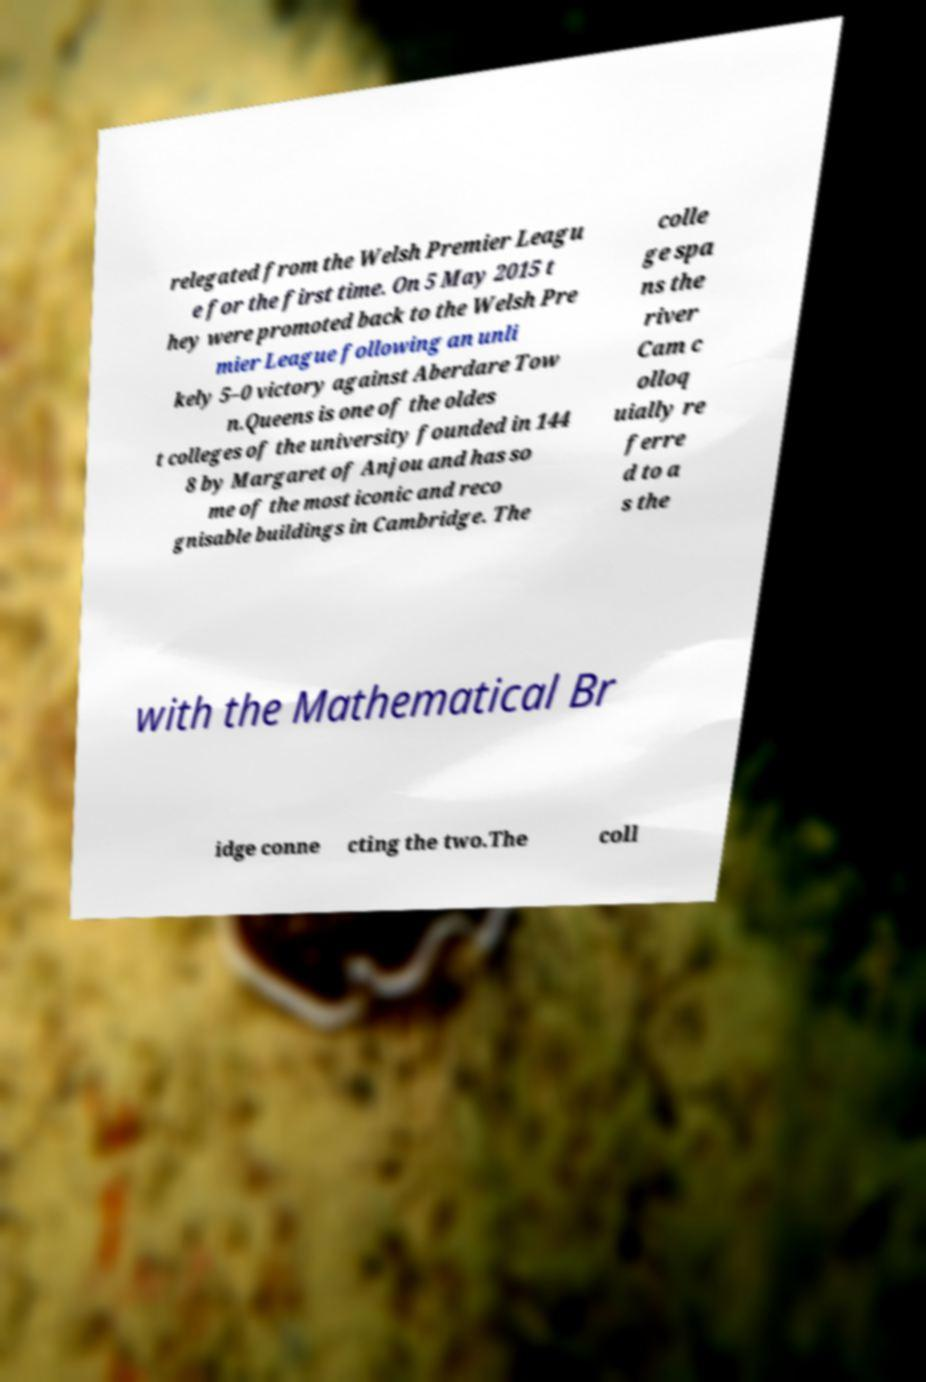Please identify and transcribe the text found in this image. relegated from the Welsh Premier Leagu e for the first time. On 5 May 2015 t hey were promoted back to the Welsh Pre mier League following an unli kely 5–0 victory against Aberdare Tow n.Queens is one of the oldes t colleges of the university founded in 144 8 by Margaret of Anjou and has so me of the most iconic and reco gnisable buildings in Cambridge. The colle ge spa ns the river Cam c olloq uially re ferre d to a s the with the Mathematical Br idge conne cting the two.The coll 